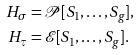<formula> <loc_0><loc_0><loc_500><loc_500>H _ { \sigma } & = \mathcal { P } [ S _ { 1 } , \dots , S _ { g } ] , \\ H _ { \tau } & = \mathcal { E } [ S _ { 1 } , \dots , S _ { g } ] .</formula> 